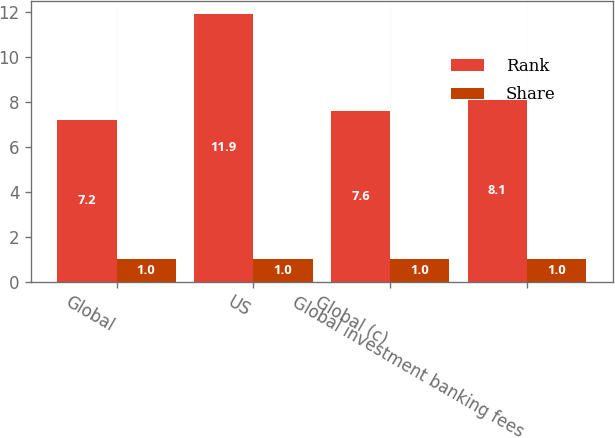Convert chart to OTSL. <chart><loc_0><loc_0><loc_500><loc_500><stacked_bar_chart><ecel><fcel>Global<fcel>US<fcel>Global (c)<fcel>Global investment banking fees<nl><fcel>Rank<fcel>7.2<fcel>11.9<fcel>7.6<fcel>8.1<nl><fcel>Share<fcel>1<fcel>1<fcel>1<fcel>1<nl></chart> 